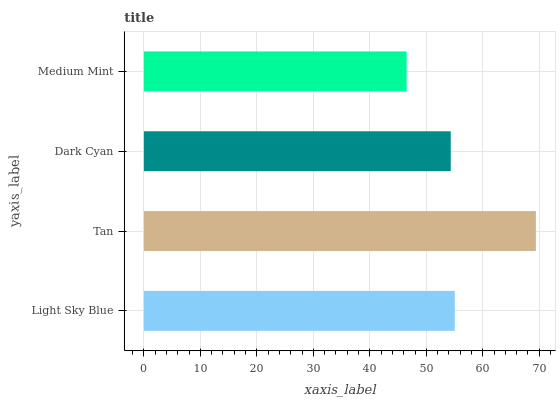Is Medium Mint the minimum?
Answer yes or no. Yes. Is Tan the maximum?
Answer yes or no. Yes. Is Dark Cyan the minimum?
Answer yes or no. No. Is Dark Cyan the maximum?
Answer yes or no. No. Is Tan greater than Dark Cyan?
Answer yes or no. Yes. Is Dark Cyan less than Tan?
Answer yes or no. Yes. Is Dark Cyan greater than Tan?
Answer yes or no. No. Is Tan less than Dark Cyan?
Answer yes or no. No. Is Light Sky Blue the high median?
Answer yes or no. Yes. Is Dark Cyan the low median?
Answer yes or no. Yes. Is Medium Mint the high median?
Answer yes or no. No. Is Tan the low median?
Answer yes or no. No. 